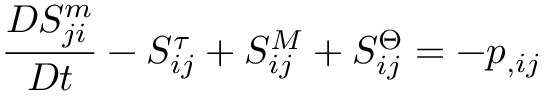Convert formula to latex. <formula><loc_0><loc_0><loc_500><loc_500>\frac { D S _ { j i } ^ { m } } { D t } - S _ { i j } ^ { \tau } + S _ { i j } ^ { M } + S _ { i j } ^ { \Theta } = - p _ { , i j }</formula> 